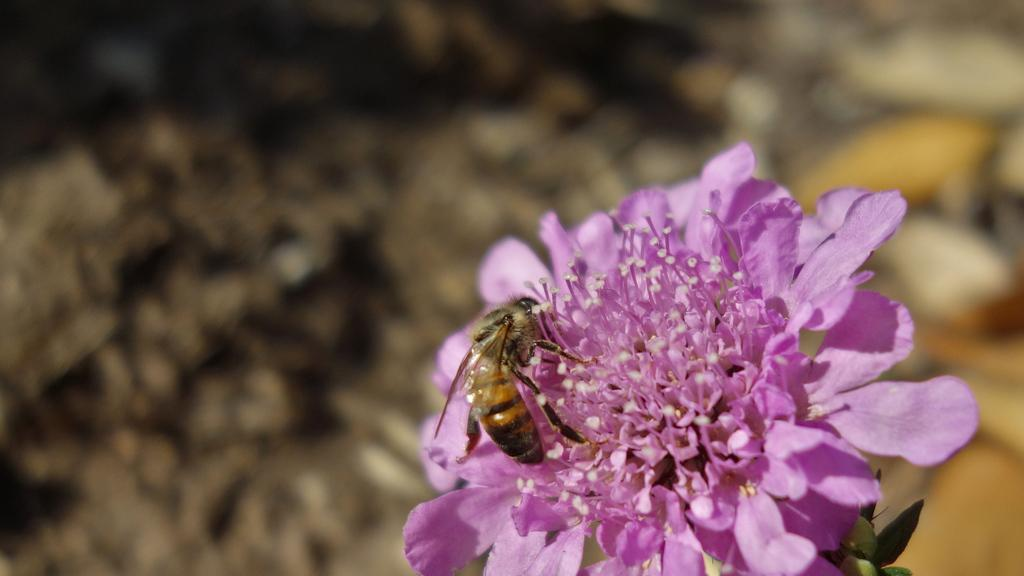What type of flower can be seen in the image? There is a pink flower in the image. Is there any other living organism interacting with the flower? Yes, a honey bee is present on the flower. Can you describe the background of the image? The background of the image is blurred. What type of calendar is hanging on the wall behind the flower? There is no calendar present in the image; it only features a pink flower and a honey bee. How many cows are visible in the image? There are no cows present in the image. 